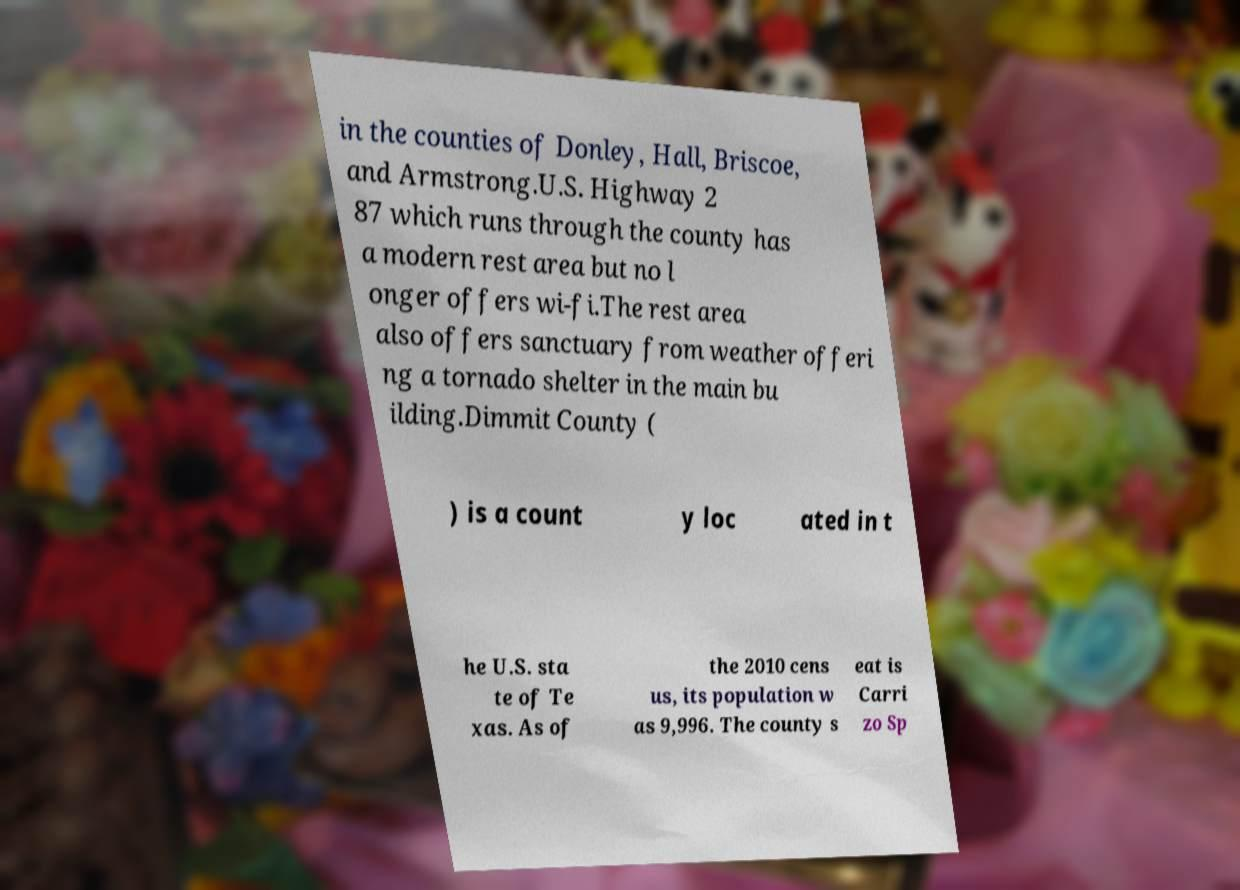Can you read and provide the text displayed in the image?This photo seems to have some interesting text. Can you extract and type it out for me? in the counties of Donley, Hall, Briscoe, and Armstrong.U.S. Highway 2 87 which runs through the county has a modern rest area but no l onger offers wi-fi.The rest area also offers sanctuary from weather offeri ng a tornado shelter in the main bu ilding.Dimmit County ( ) is a count y loc ated in t he U.S. sta te of Te xas. As of the 2010 cens us, its population w as 9,996. The county s eat is Carri zo Sp 